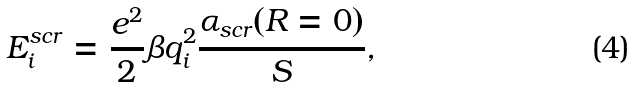<formula> <loc_0><loc_0><loc_500><loc_500>E ^ { s c r } _ { i } = \frac { e ^ { 2 } } { 2 } \beta q _ { i } ^ { 2 } \frac { \alpha _ { s c r } ( R = 0 ) } { S } ,</formula> 